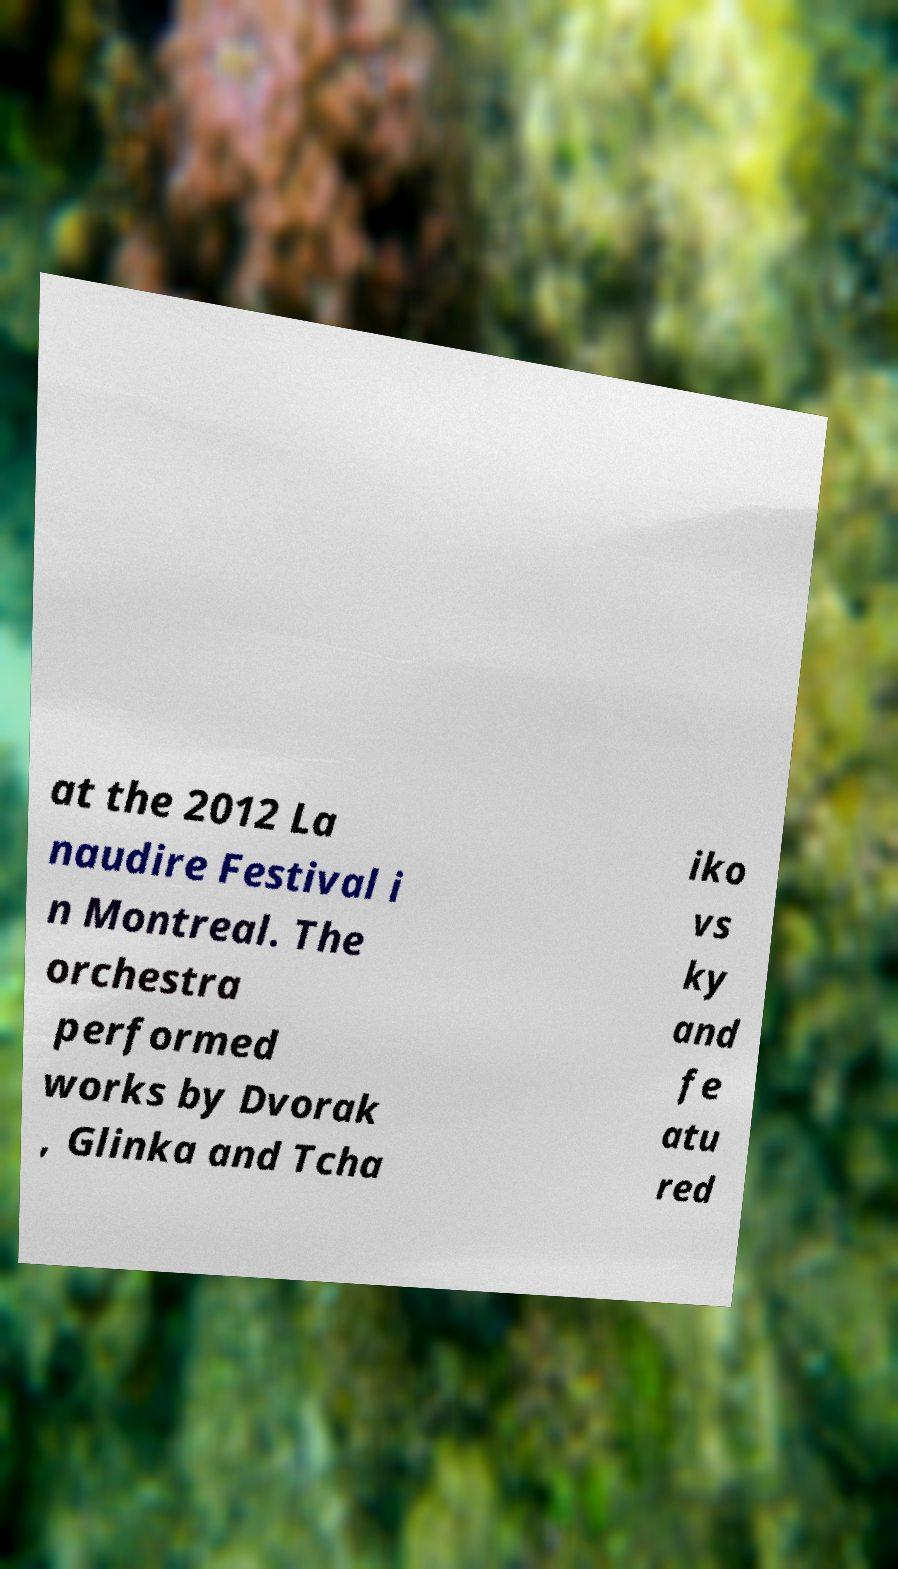Can you accurately transcribe the text from the provided image for me? at the 2012 La naudire Festival i n Montreal. The orchestra performed works by Dvorak , Glinka and Tcha iko vs ky and fe atu red 